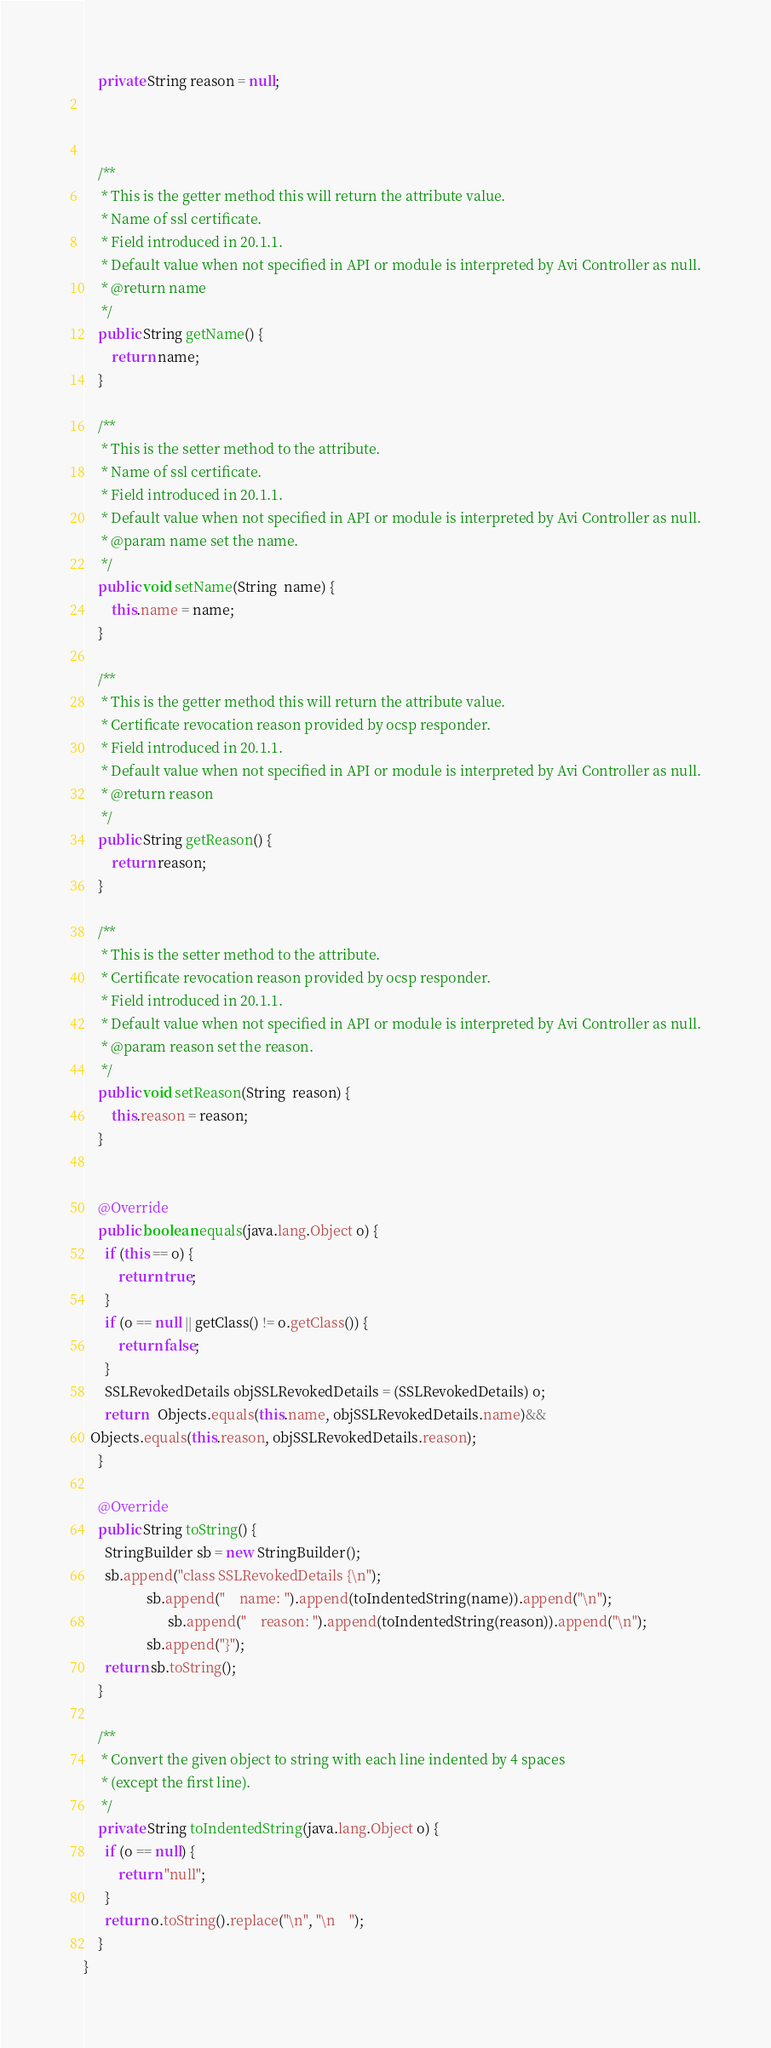<code> <loc_0><loc_0><loc_500><loc_500><_Java_>    private String reason = null;



    /**
     * This is the getter method this will return the attribute value.
     * Name of ssl certificate.
     * Field introduced in 20.1.1.
     * Default value when not specified in API or module is interpreted by Avi Controller as null.
     * @return name
     */
    public String getName() {
        return name;
    }

    /**
     * This is the setter method to the attribute.
     * Name of ssl certificate.
     * Field introduced in 20.1.1.
     * Default value when not specified in API or module is interpreted by Avi Controller as null.
     * @param name set the name.
     */
    public void setName(String  name) {
        this.name = name;
    }

    /**
     * This is the getter method this will return the attribute value.
     * Certificate revocation reason provided by ocsp responder.
     * Field introduced in 20.1.1.
     * Default value when not specified in API or module is interpreted by Avi Controller as null.
     * @return reason
     */
    public String getReason() {
        return reason;
    }

    /**
     * This is the setter method to the attribute.
     * Certificate revocation reason provided by ocsp responder.
     * Field introduced in 20.1.1.
     * Default value when not specified in API or module is interpreted by Avi Controller as null.
     * @param reason set the reason.
     */
    public void setReason(String  reason) {
        this.reason = reason;
    }


    @Override
    public boolean equals(java.lang.Object o) {
      if (this == o) {
          return true;
      }
      if (o == null || getClass() != o.getClass()) {
          return false;
      }
      SSLRevokedDetails objSSLRevokedDetails = (SSLRevokedDetails) o;
      return   Objects.equals(this.name, objSSLRevokedDetails.name)&&
  Objects.equals(this.reason, objSSLRevokedDetails.reason);
    }

    @Override
    public String toString() {
      StringBuilder sb = new StringBuilder();
      sb.append("class SSLRevokedDetails {\n");
                  sb.append("    name: ").append(toIndentedString(name)).append("\n");
                        sb.append("    reason: ").append(toIndentedString(reason)).append("\n");
                  sb.append("}");
      return sb.toString();
    }

    /**
     * Convert the given object to string with each line indented by 4 spaces
     * (except the first line).
     */
    private String toIndentedString(java.lang.Object o) {
      if (o == null) {
          return "null";
      }
      return o.toString().replace("\n", "\n    ");
    }
}
</code> 